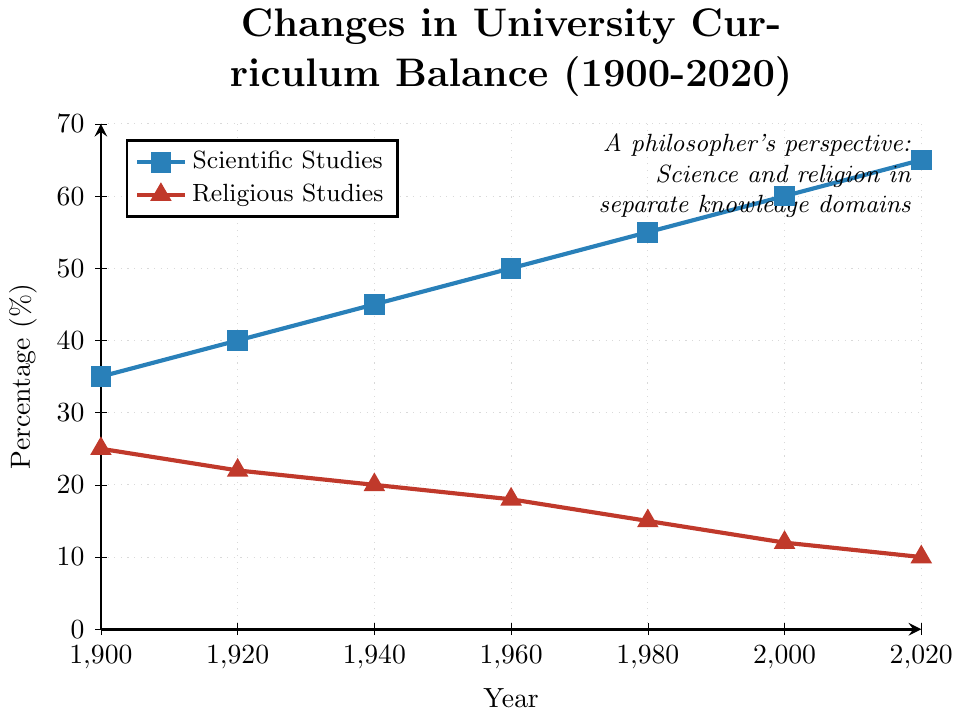What's the percentage of Scientific Studies in 1920? Locate the year 1920 on the x-axis and trace upward to the blue line, which represents Scientific Studies. Then, read the corresponding percentage from the y-axis.
Answer: 40% What's the difference in percentage between Scientific Studies and Religious Studies in 1980? For 1980, find the percentages for both Scientific (55%) and Religious Studies (15%) from the chart. Then, subtract the smaller value from the larger value: 55% - 15% = 40%
Answer: 40% How much has the percentage of Religious Studies changed from 1900 to 2020? Locate the percentages for Religious Studies in 1900 (25%) and 2020 (10%). Compute the change by subtracting the percentage in 2020 from the percentage in 1900: 25% - 10% = 15%
Answer: 15% In which year did Scientific Studies first exceed 50%? Look at the blue line representing Scientific Studies and identify the first year where the percentage exceeds 50%. This occurs between 1940 and 1960. By reading the specific value, the year is 1960.
Answer: 1960 What is the average percentage of Scientific Studies over the observed years? Calculate the average by summing the percentages for Scientific Studies across all years and then dividing by the number of years. (35 + 40 + 45 + 50 + 55 + 60 + 65) / 7 = 50
Answer: 50% By how much did the percentage of Scientific Studies increase from 1940 to 2000? Locate the values for Scientific Studies in 1940 (45%) and 2000 (60%). Subtract the value in 1940 from the value in 2000: 60% - 45% = 15%
Answer: 15% Which studies had a higher percentage in 1900, Scientific or Religious? Compare the values for Scientific Studies (35%) and Religious Studies (25%) in 1900. Since 35% > 25%, Scientific Studies had a higher percentage.
Answer: Scientific Studies What's the rate of increase in Scientific Studies percentage from 1960 to 1980? Calculate the increase in percentage from 1960 (50%) to 1980 (55%) and divide by the number of years (1980 - 1960 = 20 years). (55% - 50%) / 20 years = 0.25% per year
Answer: 0.25% per year What's the combined percentage of Scientific and Religious Studies in 2000? Add the percentages of Scientific Studies (60%) and Religious Studies (12%) in 2000: 60% + 12% = 72%
Answer: 72% How does the color represent different lines in the plot? The blue line represents Scientific Studies, and the red line represents Religious Studies, distinguishable by their markers and colors in the legend and plot.
Answer: Blue for Scientific, Red for Religious 